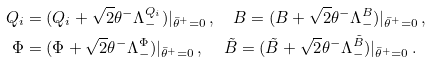Convert formula to latex. <formula><loc_0><loc_0><loc_500><loc_500>Q _ { i } & = ( Q _ { i } + \sqrt { 2 } \theta ^ { - } \Lambda ^ { Q _ { i } } _ { - } ) | _ { \bar { \theta } ^ { + } = 0 } \, , \quad B = ( B + \sqrt { 2 } \theta ^ { - } \Lambda ^ { B } _ { - } ) | _ { \bar { \theta } ^ { + } = 0 } \, , \\ \Phi & = ( \Phi + \sqrt { 2 } \theta ^ { - } \Lambda ^ { \Phi } _ { - } ) | _ { \bar { \theta } ^ { + } = 0 } \, , \quad \, \tilde { B } = ( \tilde { B } + \sqrt { 2 } \theta ^ { - } \Lambda ^ { \tilde { B } } _ { - } ) | _ { \bar { \theta } ^ { + } = 0 } \, .</formula> 